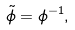Convert formula to latex. <formula><loc_0><loc_0><loc_500><loc_500>\tilde { \phi } = \phi ^ { - 1 } ,</formula> 